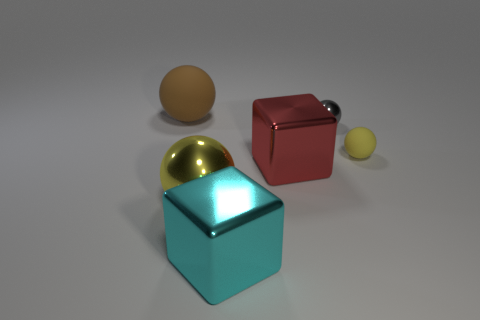There is a metal ball that is the same color as the tiny matte sphere; what is its size?
Your answer should be very brief. Large. What is the material of the block that is behind the big ball that is to the right of the brown matte thing?
Offer a terse response. Metal. The red block that is the same material as the large cyan cube is what size?
Your answer should be very brief. Large. There is a rubber thing that is the same color as the large metallic sphere; what shape is it?
Give a very brief answer. Sphere. There is a matte object that is in front of the big brown rubber object; is it the same shape as the yellow thing that is left of the tiny metal thing?
Provide a succinct answer. Yes. What shape is the cyan thing that is the same material as the large red object?
Your response must be concise. Cube. There is a small matte ball; is its color the same as the metallic sphere that is on the left side of the red object?
Provide a short and direct response. Yes. There is a big sphere behind the tiny metal sphere; what is its material?
Offer a terse response. Rubber. The large cyan object in front of the matte ball on the right side of the rubber thing behind the tiny gray shiny sphere is what shape?
Offer a terse response. Cube. Are there any small yellow rubber balls on the right side of the brown rubber thing?
Offer a very short reply. Yes. 